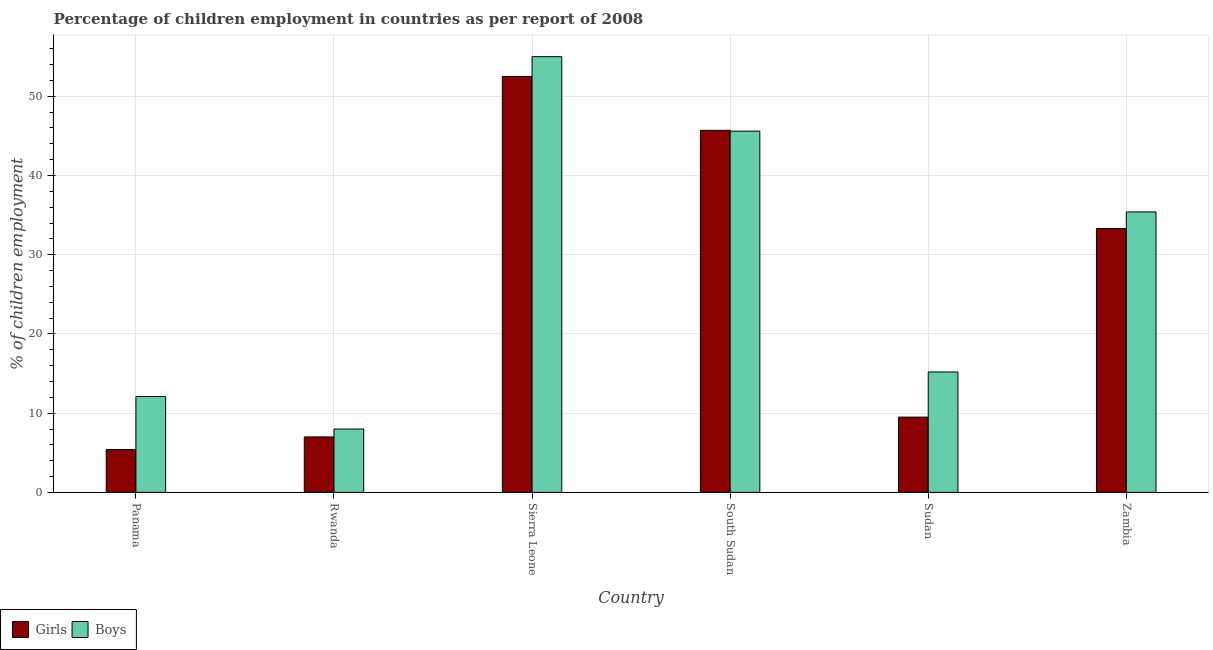How many different coloured bars are there?
Offer a terse response. 2. Are the number of bars per tick equal to the number of legend labels?
Ensure brevity in your answer.  Yes. Are the number of bars on each tick of the X-axis equal?
Your response must be concise. Yes. What is the label of the 6th group of bars from the left?
Make the answer very short. Zambia. In how many cases, is the number of bars for a given country not equal to the number of legend labels?
Offer a very short reply. 0. Across all countries, what is the maximum percentage of employed girls?
Make the answer very short. 52.5. Across all countries, what is the minimum percentage of employed boys?
Ensure brevity in your answer.  8. In which country was the percentage of employed girls maximum?
Offer a terse response. Sierra Leone. In which country was the percentage of employed girls minimum?
Your answer should be compact. Panama. What is the total percentage of employed boys in the graph?
Provide a succinct answer. 171.3. What is the difference between the percentage of employed girls in Rwanda and that in Zambia?
Your answer should be compact. -26.3. What is the difference between the percentage of employed boys in Rwanda and the percentage of employed girls in South Sudan?
Offer a very short reply. -37.7. What is the average percentage of employed boys per country?
Keep it short and to the point. 28.55. What is the difference between the percentage of employed girls and percentage of employed boys in Sierra Leone?
Ensure brevity in your answer.  -2.5. In how many countries, is the percentage of employed boys greater than 10 %?
Your response must be concise. 5. What is the ratio of the percentage of employed boys in Sierra Leone to that in Zambia?
Your answer should be very brief. 1.55. Is the percentage of employed boys in Rwanda less than that in South Sudan?
Offer a very short reply. Yes. Is the difference between the percentage of employed boys in Panama and Zambia greater than the difference between the percentage of employed girls in Panama and Zambia?
Your answer should be very brief. Yes. What is the difference between the highest and the second highest percentage of employed boys?
Make the answer very short. 9.4. What is the difference between the highest and the lowest percentage of employed girls?
Provide a succinct answer. 47.1. In how many countries, is the percentage of employed boys greater than the average percentage of employed boys taken over all countries?
Provide a succinct answer. 3. Is the sum of the percentage of employed girls in Sierra Leone and Sudan greater than the maximum percentage of employed boys across all countries?
Your response must be concise. Yes. What does the 2nd bar from the left in Zambia represents?
Your answer should be compact. Boys. What does the 2nd bar from the right in Sudan represents?
Make the answer very short. Girls. How many bars are there?
Your answer should be compact. 12. Are all the bars in the graph horizontal?
Ensure brevity in your answer.  No. What is the difference between two consecutive major ticks on the Y-axis?
Make the answer very short. 10. Are the values on the major ticks of Y-axis written in scientific E-notation?
Ensure brevity in your answer.  No. Does the graph contain grids?
Ensure brevity in your answer.  Yes. How many legend labels are there?
Provide a short and direct response. 2. What is the title of the graph?
Offer a terse response. Percentage of children employment in countries as per report of 2008. What is the label or title of the X-axis?
Make the answer very short. Country. What is the label or title of the Y-axis?
Give a very brief answer. % of children employment. What is the % of children employment in Girls in Panama?
Make the answer very short. 5.4. What is the % of children employment of Girls in Rwanda?
Provide a short and direct response. 7. What is the % of children employment of Girls in Sierra Leone?
Offer a terse response. 52.5. What is the % of children employment in Girls in South Sudan?
Provide a succinct answer. 45.7. What is the % of children employment of Boys in South Sudan?
Your response must be concise. 45.6. What is the % of children employment of Boys in Sudan?
Give a very brief answer. 15.2. What is the % of children employment of Girls in Zambia?
Offer a terse response. 33.3. What is the % of children employment in Boys in Zambia?
Ensure brevity in your answer.  35.4. Across all countries, what is the maximum % of children employment of Girls?
Provide a short and direct response. 52.5. Across all countries, what is the maximum % of children employment of Boys?
Give a very brief answer. 55. What is the total % of children employment in Girls in the graph?
Provide a short and direct response. 153.4. What is the total % of children employment of Boys in the graph?
Give a very brief answer. 171.3. What is the difference between the % of children employment in Boys in Panama and that in Rwanda?
Your answer should be compact. 4.1. What is the difference between the % of children employment in Girls in Panama and that in Sierra Leone?
Keep it short and to the point. -47.1. What is the difference between the % of children employment in Boys in Panama and that in Sierra Leone?
Make the answer very short. -42.9. What is the difference between the % of children employment of Girls in Panama and that in South Sudan?
Ensure brevity in your answer.  -40.3. What is the difference between the % of children employment in Boys in Panama and that in South Sudan?
Your answer should be compact. -33.5. What is the difference between the % of children employment in Girls in Panama and that in Sudan?
Your answer should be very brief. -4.1. What is the difference between the % of children employment in Boys in Panama and that in Sudan?
Your answer should be compact. -3.1. What is the difference between the % of children employment in Girls in Panama and that in Zambia?
Ensure brevity in your answer.  -27.9. What is the difference between the % of children employment in Boys in Panama and that in Zambia?
Keep it short and to the point. -23.3. What is the difference between the % of children employment in Girls in Rwanda and that in Sierra Leone?
Your answer should be very brief. -45.5. What is the difference between the % of children employment in Boys in Rwanda and that in Sierra Leone?
Ensure brevity in your answer.  -47. What is the difference between the % of children employment of Girls in Rwanda and that in South Sudan?
Provide a succinct answer. -38.7. What is the difference between the % of children employment in Boys in Rwanda and that in South Sudan?
Offer a terse response. -37.6. What is the difference between the % of children employment of Boys in Rwanda and that in Sudan?
Offer a very short reply. -7.2. What is the difference between the % of children employment of Girls in Rwanda and that in Zambia?
Provide a short and direct response. -26.3. What is the difference between the % of children employment of Boys in Rwanda and that in Zambia?
Your response must be concise. -27.4. What is the difference between the % of children employment in Girls in Sierra Leone and that in South Sudan?
Ensure brevity in your answer.  6.8. What is the difference between the % of children employment in Girls in Sierra Leone and that in Sudan?
Your answer should be compact. 43. What is the difference between the % of children employment of Boys in Sierra Leone and that in Sudan?
Your response must be concise. 39.8. What is the difference between the % of children employment of Boys in Sierra Leone and that in Zambia?
Ensure brevity in your answer.  19.6. What is the difference between the % of children employment of Girls in South Sudan and that in Sudan?
Offer a terse response. 36.2. What is the difference between the % of children employment of Boys in South Sudan and that in Sudan?
Provide a succinct answer. 30.4. What is the difference between the % of children employment of Girls in South Sudan and that in Zambia?
Your answer should be very brief. 12.4. What is the difference between the % of children employment in Boys in South Sudan and that in Zambia?
Offer a very short reply. 10.2. What is the difference between the % of children employment in Girls in Sudan and that in Zambia?
Provide a short and direct response. -23.8. What is the difference between the % of children employment in Boys in Sudan and that in Zambia?
Ensure brevity in your answer.  -20.2. What is the difference between the % of children employment in Girls in Panama and the % of children employment in Boys in Rwanda?
Offer a terse response. -2.6. What is the difference between the % of children employment of Girls in Panama and the % of children employment of Boys in Sierra Leone?
Provide a succinct answer. -49.6. What is the difference between the % of children employment of Girls in Panama and the % of children employment of Boys in South Sudan?
Your answer should be compact. -40.2. What is the difference between the % of children employment in Girls in Rwanda and the % of children employment in Boys in Sierra Leone?
Provide a short and direct response. -48. What is the difference between the % of children employment in Girls in Rwanda and the % of children employment in Boys in South Sudan?
Make the answer very short. -38.6. What is the difference between the % of children employment in Girls in Rwanda and the % of children employment in Boys in Sudan?
Ensure brevity in your answer.  -8.2. What is the difference between the % of children employment in Girls in Rwanda and the % of children employment in Boys in Zambia?
Offer a terse response. -28.4. What is the difference between the % of children employment of Girls in Sierra Leone and the % of children employment of Boys in South Sudan?
Provide a short and direct response. 6.9. What is the difference between the % of children employment in Girls in Sierra Leone and the % of children employment in Boys in Sudan?
Offer a terse response. 37.3. What is the difference between the % of children employment of Girls in Sierra Leone and the % of children employment of Boys in Zambia?
Provide a succinct answer. 17.1. What is the difference between the % of children employment in Girls in South Sudan and the % of children employment in Boys in Sudan?
Your answer should be very brief. 30.5. What is the difference between the % of children employment in Girls in Sudan and the % of children employment in Boys in Zambia?
Your response must be concise. -25.9. What is the average % of children employment of Girls per country?
Your response must be concise. 25.57. What is the average % of children employment in Boys per country?
Offer a terse response. 28.55. What is the difference between the % of children employment in Girls and % of children employment in Boys in Panama?
Ensure brevity in your answer.  -6.7. What is the difference between the % of children employment in Girls and % of children employment in Boys in Sierra Leone?
Provide a short and direct response. -2.5. What is the difference between the % of children employment in Girls and % of children employment in Boys in Zambia?
Ensure brevity in your answer.  -2.1. What is the ratio of the % of children employment in Girls in Panama to that in Rwanda?
Give a very brief answer. 0.77. What is the ratio of the % of children employment of Boys in Panama to that in Rwanda?
Your answer should be very brief. 1.51. What is the ratio of the % of children employment in Girls in Panama to that in Sierra Leone?
Ensure brevity in your answer.  0.1. What is the ratio of the % of children employment in Boys in Panama to that in Sierra Leone?
Offer a very short reply. 0.22. What is the ratio of the % of children employment in Girls in Panama to that in South Sudan?
Provide a succinct answer. 0.12. What is the ratio of the % of children employment in Boys in Panama to that in South Sudan?
Ensure brevity in your answer.  0.27. What is the ratio of the % of children employment in Girls in Panama to that in Sudan?
Offer a terse response. 0.57. What is the ratio of the % of children employment of Boys in Panama to that in Sudan?
Make the answer very short. 0.8. What is the ratio of the % of children employment in Girls in Panama to that in Zambia?
Keep it short and to the point. 0.16. What is the ratio of the % of children employment in Boys in Panama to that in Zambia?
Your response must be concise. 0.34. What is the ratio of the % of children employment of Girls in Rwanda to that in Sierra Leone?
Keep it short and to the point. 0.13. What is the ratio of the % of children employment of Boys in Rwanda to that in Sierra Leone?
Give a very brief answer. 0.15. What is the ratio of the % of children employment in Girls in Rwanda to that in South Sudan?
Make the answer very short. 0.15. What is the ratio of the % of children employment in Boys in Rwanda to that in South Sudan?
Make the answer very short. 0.18. What is the ratio of the % of children employment of Girls in Rwanda to that in Sudan?
Offer a very short reply. 0.74. What is the ratio of the % of children employment in Boys in Rwanda to that in Sudan?
Make the answer very short. 0.53. What is the ratio of the % of children employment of Girls in Rwanda to that in Zambia?
Provide a short and direct response. 0.21. What is the ratio of the % of children employment of Boys in Rwanda to that in Zambia?
Your answer should be very brief. 0.23. What is the ratio of the % of children employment of Girls in Sierra Leone to that in South Sudan?
Offer a very short reply. 1.15. What is the ratio of the % of children employment of Boys in Sierra Leone to that in South Sudan?
Offer a very short reply. 1.21. What is the ratio of the % of children employment of Girls in Sierra Leone to that in Sudan?
Offer a very short reply. 5.53. What is the ratio of the % of children employment in Boys in Sierra Leone to that in Sudan?
Make the answer very short. 3.62. What is the ratio of the % of children employment in Girls in Sierra Leone to that in Zambia?
Your response must be concise. 1.58. What is the ratio of the % of children employment of Boys in Sierra Leone to that in Zambia?
Keep it short and to the point. 1.55. What is the ratio of the % of children employment in Girls in South Sudan to that in Sudan?
Provide a succinct answer. 4.81. What is the ratio of the % of children employment of Girls in South Sudan to that in Zambia?
Ensure brevity in your answer.  1.37. What is the ratio of the % of children employment in Boys in South Sudan to that in Zambia?
Your answer should be very brief. 1.29. What is the ratio of the % of children employment in Girls in Sudan to that in Zambia?
Provide a short and direct response. 0.29. What is the ratio of the % of children employment of Boys in Sudan to that in Zambia?
Ensure brevity in your answer.  0.43. What is the difference between the highest and the second highest % of children employment in Girls?
Provide a short and direct response. 6.8. What is the difference between the highest and the second highest % of children employment of Boys?
Your answer should be very brief. 9.4. What is the difference between the highest and the lowest % of children employment in Girls?
Keep it short and to the point. 47.1. What is the difference between the highest and the lowest % of children employment in Boys?
Give a very brief answer. 47. 